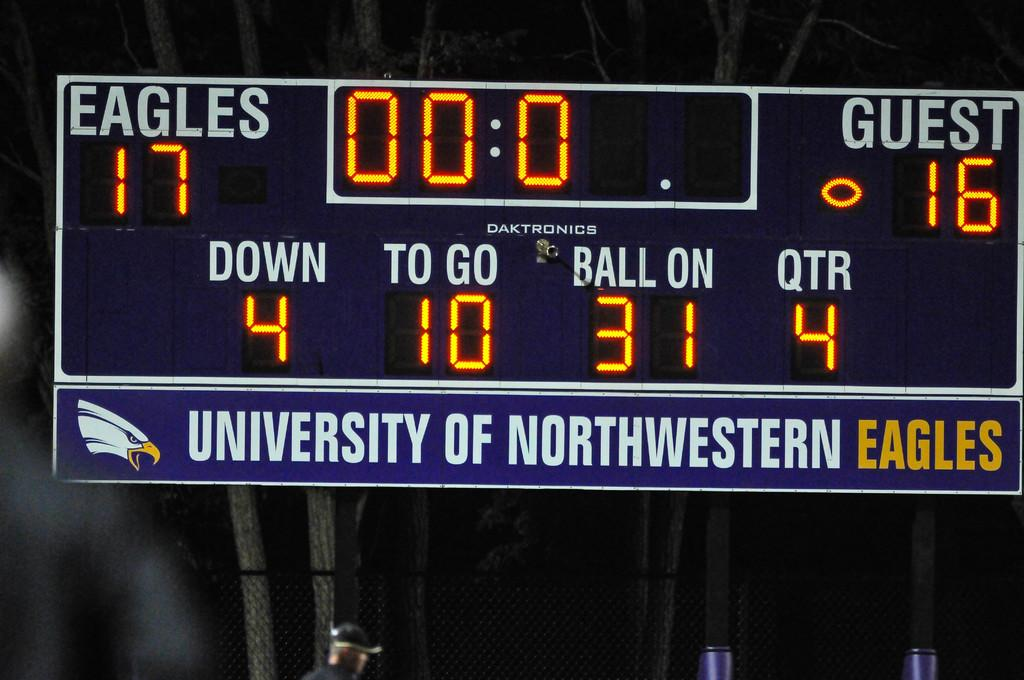<image>
Relay a brief, clear account of the picture shown. Univeristy of Northweatern score board who have one by one point 